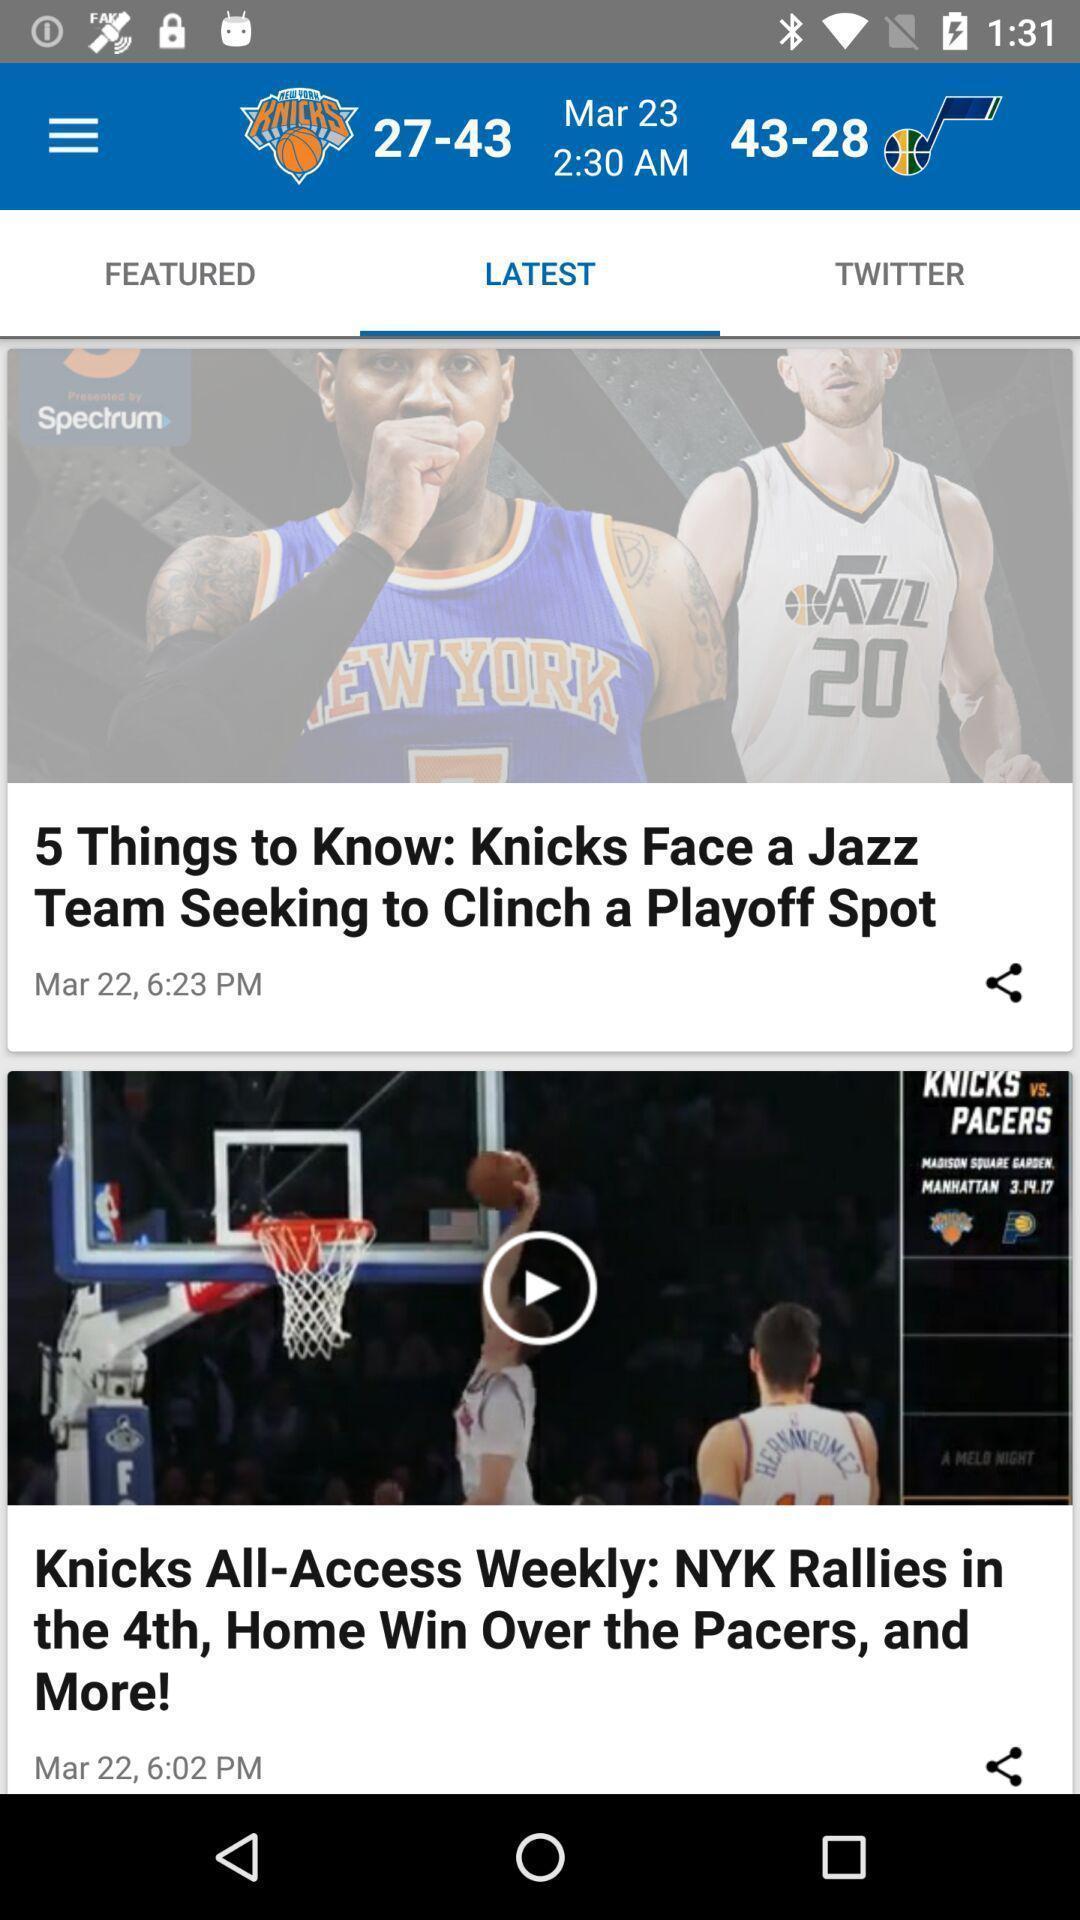Explain what's happening in this screen capture. Screen shows latest articles in sports app. 